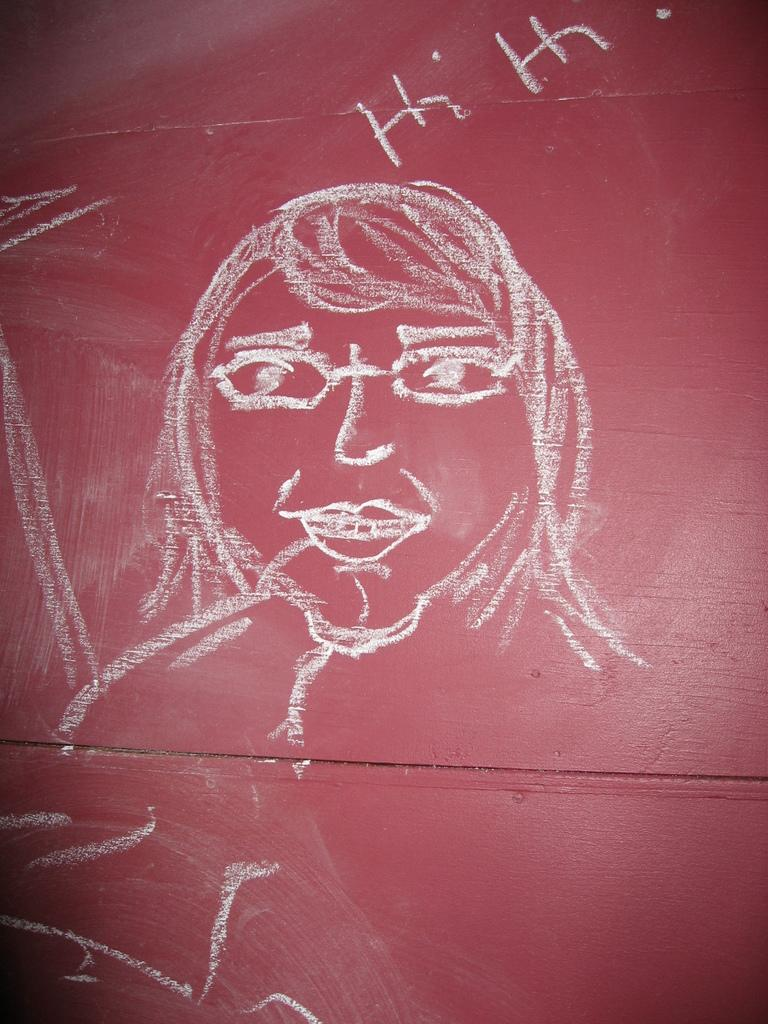What is depicted on the wall in the image? There is a drawing on the wall in the image. Can you see any squirrels climbing the icicles in the image? There are no squirrels or icicles present in the image; it only features a drawing on the wall. 